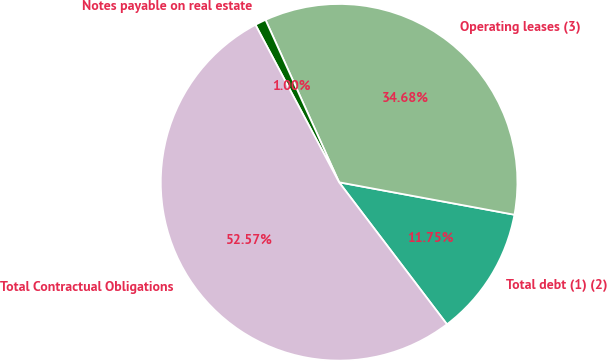<chart> <loc_0><loc_0><loc_500><loc_500><pie_chart><fcel>Total debt (1) (2)<fcel>Operating leases (3)<fcel>Notes payable on real estate<fcel>Total Contractual Obligations<nl><fcel>11.75%<fcel>34.68%<fcel>1.0%<fcel>52.57%<nl></chart> 